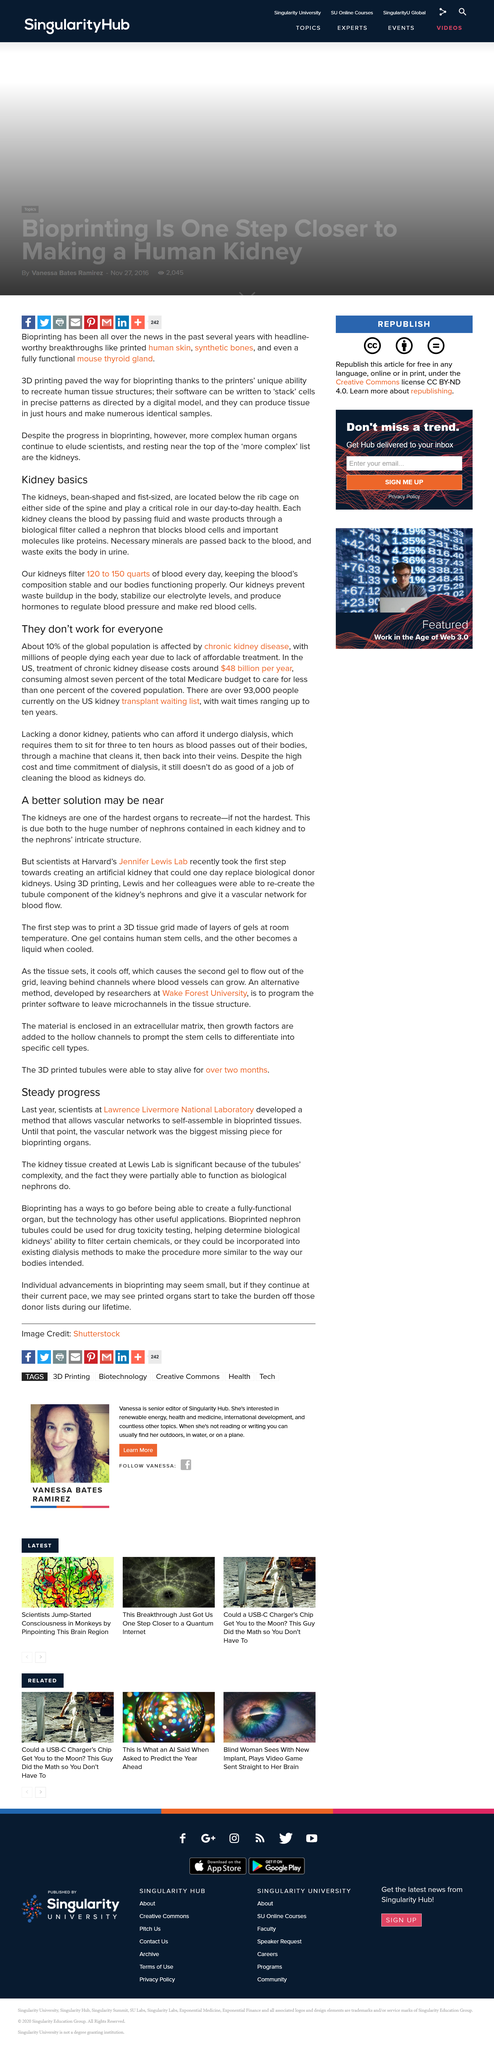Outline some significant characteristics in this image. Bioprinting is unable to produce a fully-functional organ. Chronic kidney disease affects approximately 10% of the global population. This equates to millions of individuals worldwide who are affected by this debilitating and often life-threatening condition. Patients who are awaiting a donor kidney and cannot afford dialysis undergo dialysis. Steady progress" is the title of this article. According to the United States, the annual cost of treating chronic kidney disease is approximately $48 billion. 